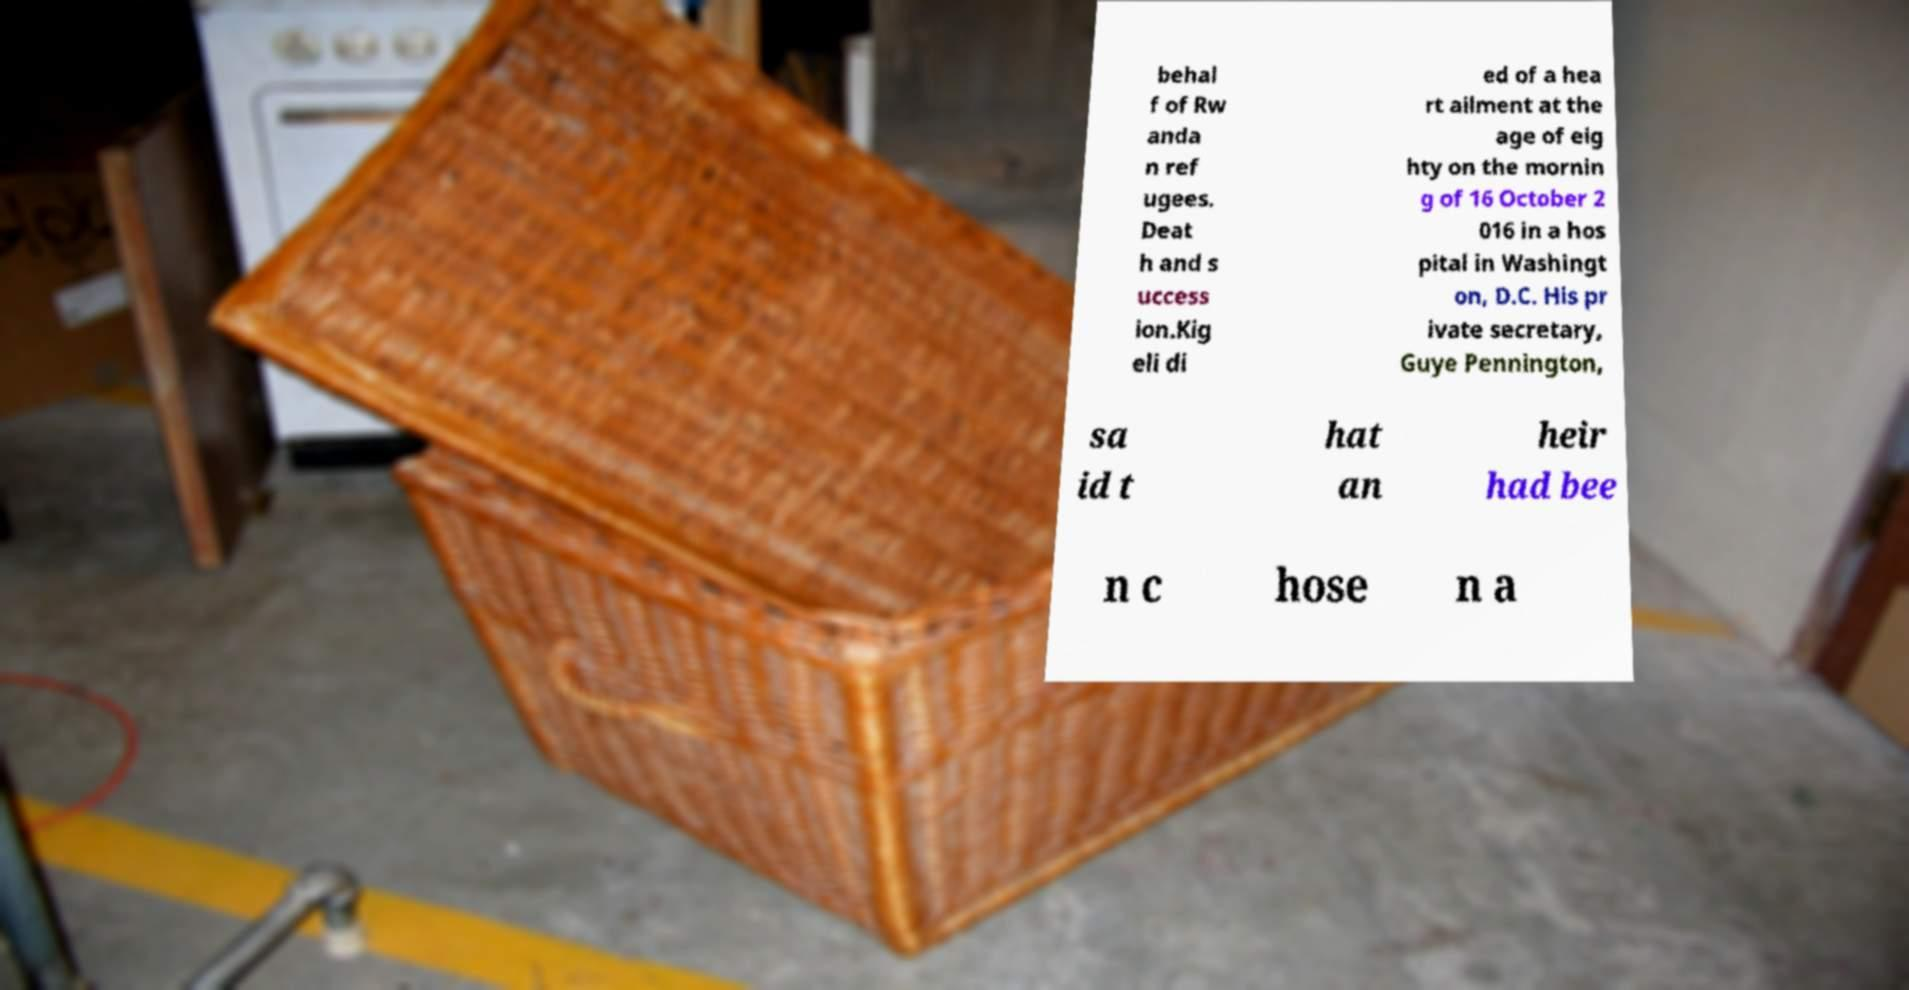For documentation purposes, I need the text within this image transcribed. Could you provide that? behal f of Rw anda n ref ugees. Deat h and s uccess ion.Kig eli di ed of a hea rt ailment at the age of eig hty on the mornin g of 16 October 2 016 in a hos pital in Washingt on, D.C. His pr ivate secretary, Guye Pennington, sa id t hat an heir had bee n c hose n a 